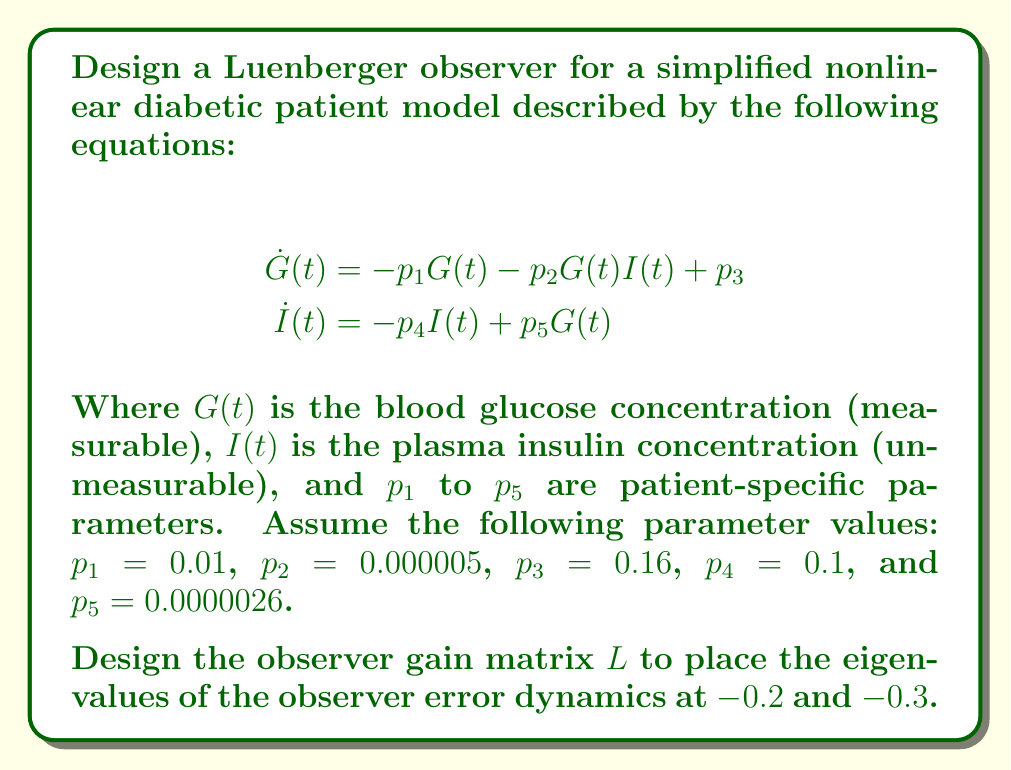Can you solve this math problem? To design a Luenberger observer for this nonlinear system, we need to follow these steps:

1) Linearize the system around an equilibrium point.
2) Determine the observability of the linearized system.
3) Design the observer gain matrix $L$.

Step 1: Linearization

First, find the equilibrium point by setting $\dot{G} = \dot{I} = 0$:

$$\begin{align}
0 &= -p_1G_e - p_2G_eI_e + p_3 \\
0 &= -p_4I_e + p_5G_e
\end{align}$$

Solving these equations gives $G_e \approx 100$ mg/dL and $I_e \approx 26$ µU/mL.

Now, linearize the system around this equilibrium point:

$$\begin{bmatrix} \dot{G} \\ \dot{I} \end{bmatrix} = \begin{bmatrix} -p_1 - p_2I_e & -p_2G_e \\ p_5 & -p_4 \end{bmatrix} \begin{bmatrix} G - G_e \\ I - I_e \end{bmatrix}$$

The linearized system matrix $A$ is:

$$A = \begin{bmatrix} -0.0113 & -0.0005 \\ 0.0000026 & -0.1 \end{bmatrix}$$

The output matrix $C$ for measuring only glucose is:

$$C = \begin{bmatrix} 1 & 0 \end{bmatrix}$$

Step 2: Observability

Check the observability of the linearized system:

$$O = \begin{bmatrix} C \\ CA \end{bmatrix} = \begin{bmatrix} 1 & 0 \\ -0.0113 & -0.0005 \end{bmatrix}$$

The rank of $O$ is 2, equal to the system order, so the system is observable.

Step 3: Observer Design

For the Luenberger observer, we need to find $L$ such that $(A - LC)$ has the desired eigenvalues $-0.2$ and $-0.3$.

The characteristic equation of $(A - LC)$ is:

$$\det(sI - (A - LC)) = s^2 + (0.1113 + l_1)s + (0.00113 + 0.1l_1 + 0.0000026l_2) = 0$$

Comparing this with the desired characteristic equation $(s + 0.2)(s + 0.3) = s^2 + 0.5s + 0.06$, we get:

$$\begin{align}
0.1113 + l_1 &= 0.5 \\
0.00113 + 0.1l_1 + 0.0000026l_2 &= 0.06
\end{align}$$

Solving these equations gives:

$$\begin{align}
l_1 &\approx 0.3887 \\
l_2 &\approx 22565.38
\end{align}$$

Therefore, the observer gain matrix is:

$$L = \begin{bmatrix} 0.3887 \\ 22565.38 \end{bmatrix}$$
Answer: The Luenberger observer gain matrix for the given nonlinear diabetic patient model is:

$$L = \begin{bmatrix} 0.3887 \\ 22565.38 \end{bmatrix}$$

This gain matrix will place the eigenvalues of the observer error dynamics at $-0.2$ and $-0.3$, allowing for estimation of the unmeasurable plasma insulin concentration. 